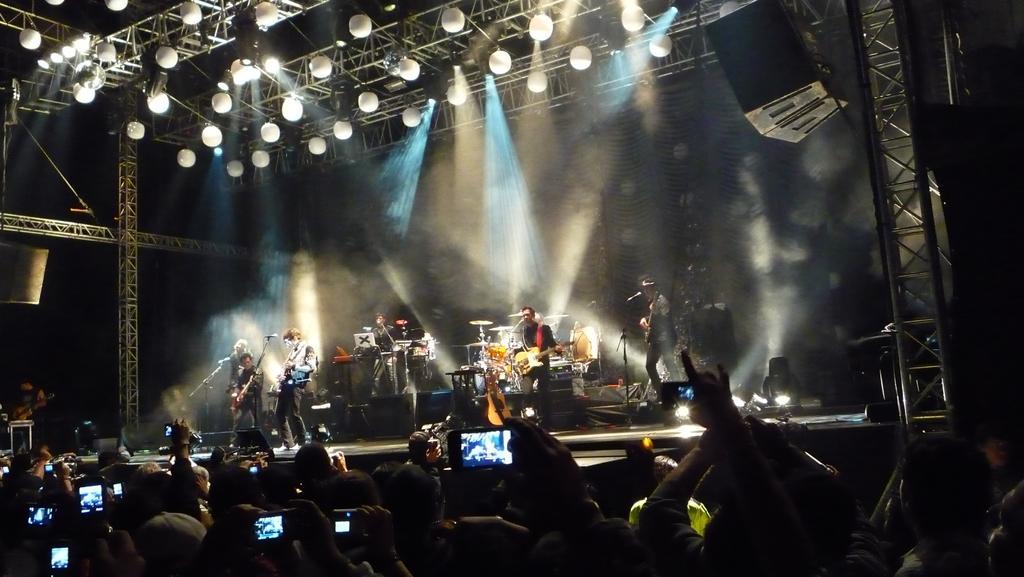Describe this image in one or two sentences. In this image I can see the group of people and I can see few people holding the mobiles. In-front of these people I can see few more people playing the musical instruments. These people are on the stage. I can see the lights in the top. 